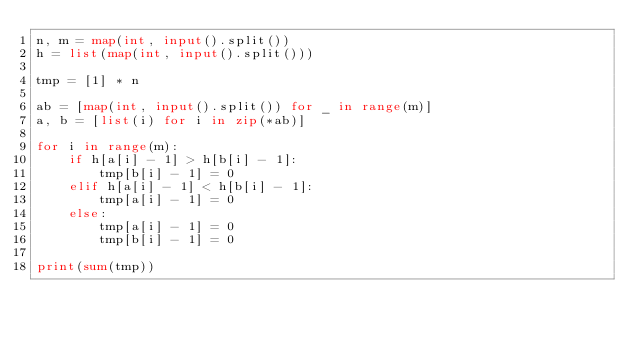Convert code to text. <code><loc_0><loc_0><loc_500><loc_500><_Python_>n, m = map(int, input().split())
h = list(map(int, input().split()))

tmp = [1] * n

ab = [map(int, input().split()) for _ in range(m)]
a, b = [list(i) for i in zip(*ab)]

for i in range(m):
    if h[a[i] - 1] > h[b[i] - 1]:
        tmp[b[i] - 1] = 0
    elif h[a[i] - 1] < h[b[i] - 1]:
        tmp[a[i] - 1] = 0
    else:
        tmp[a[i] - 1] = 0
        tmp[b[i] - 1] = 0

print(sum(tmp))</code> 